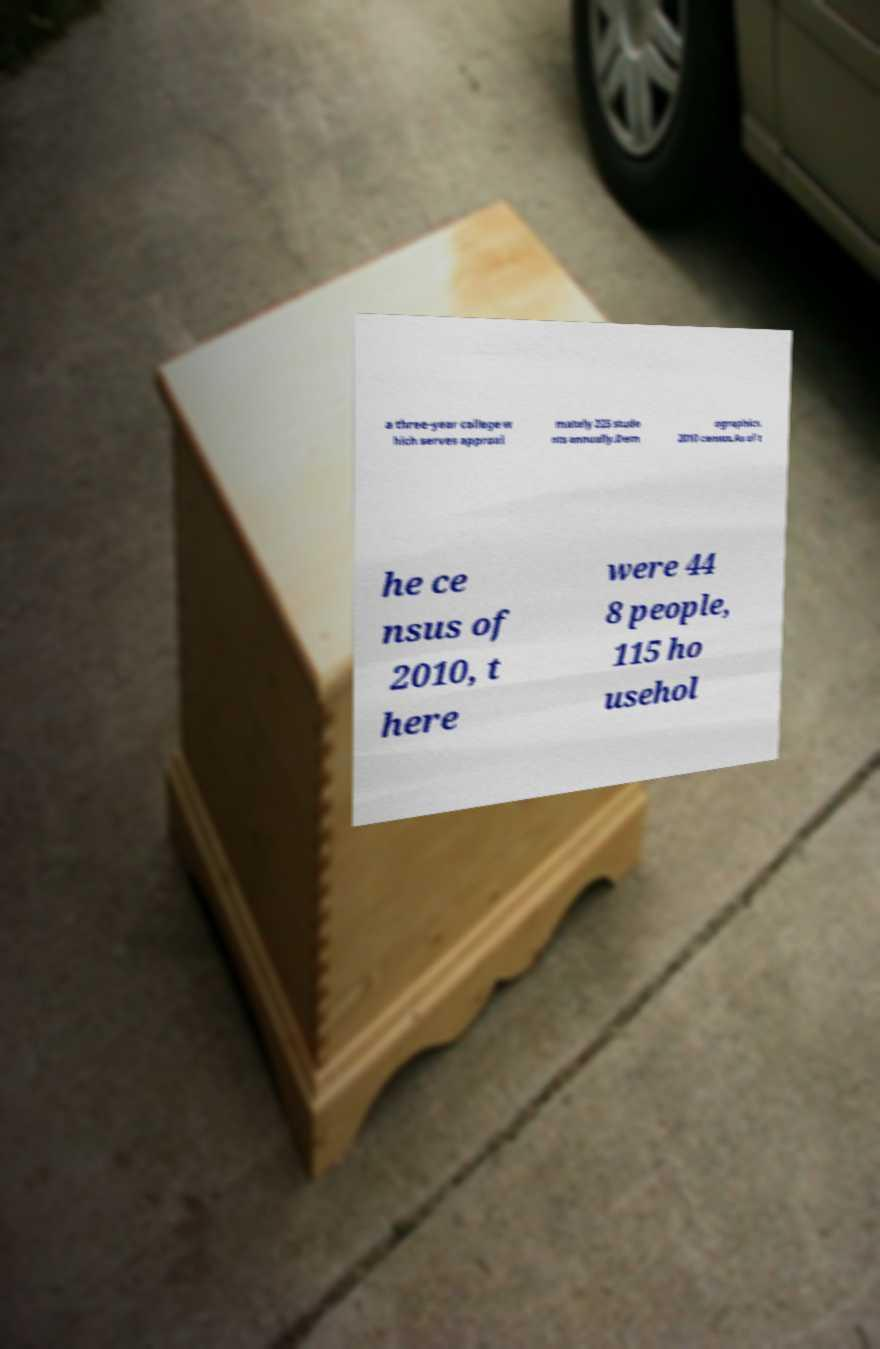Could you extract and type out the text from this image? a three-year college w hich serves approxi mately 225 stude nts annually.Dem ographics. 2010 census.As of t he ce nsus of 2010, t here were 44 8 people, 115 ho usehol 